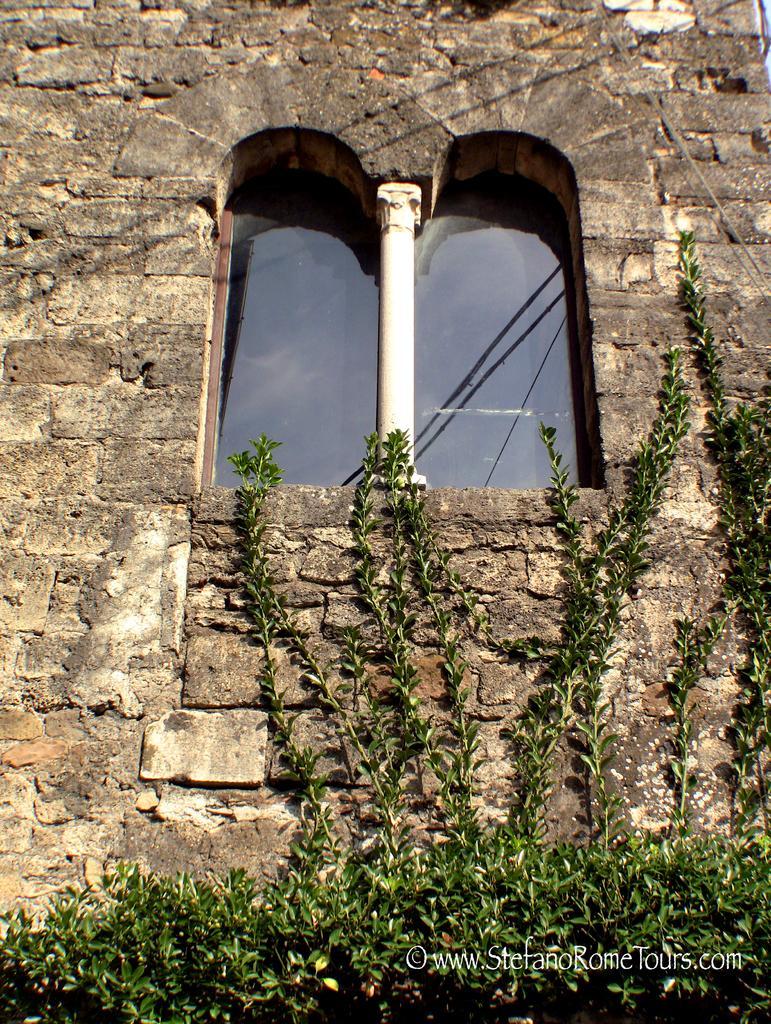How would you summarize this image in a sentence or two? In this image we can see plants, wall built with cobblestones and windows. 